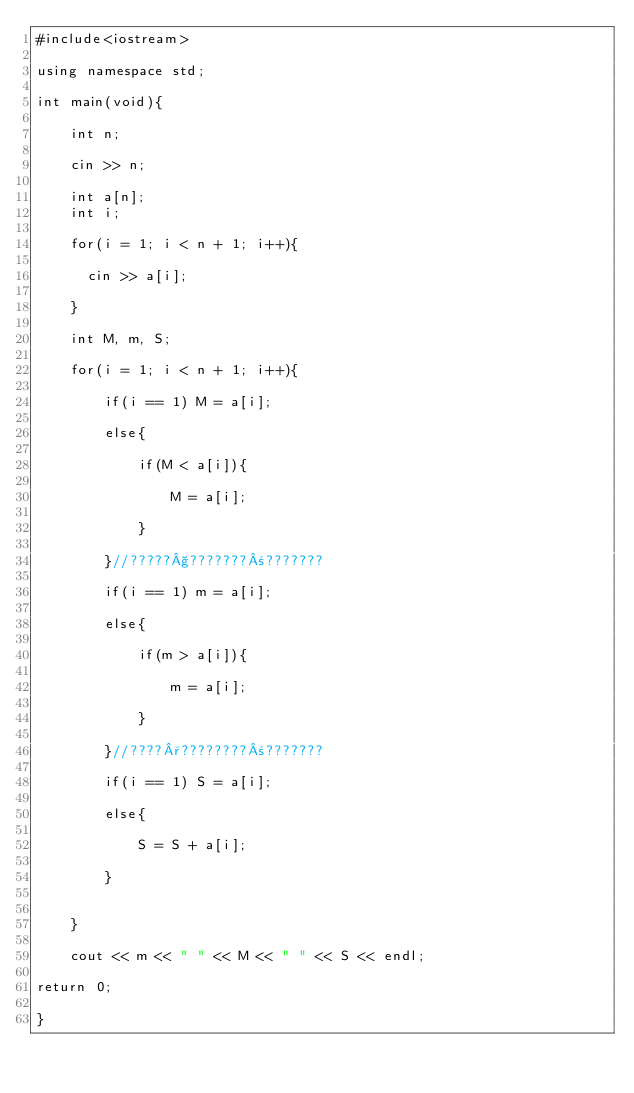Convert code to text. <code><loc_0><loc_0><loc_500><loc_500><_C++_>#include<iostream>

using namespace std;

int main(void){

    int n;

    cin >> n;

    int a[n];
    int i;

    for(i = 1; i < n + 1; i++){

      cin >> a[i];

    }

    int M, m, S;

    for(i = 1; i < n + 1; i++){

        if(i == 1) M = a[i];

        else{
            
            if(M < a[i]){

                M = a[i];

            }
            
        }//?????§???????±???????

        if(i == 1) m = a[i];

        else{

            if(m > a[i]){

                m = a[i];

            }

        }//????°????????±???????

        if(i == 1) S = a[i];

        else{
            
            S = S + a[i];
        
        }

        
    }

    cout << m << " " << M << " " << S << endl;

return 0;

}</code> 